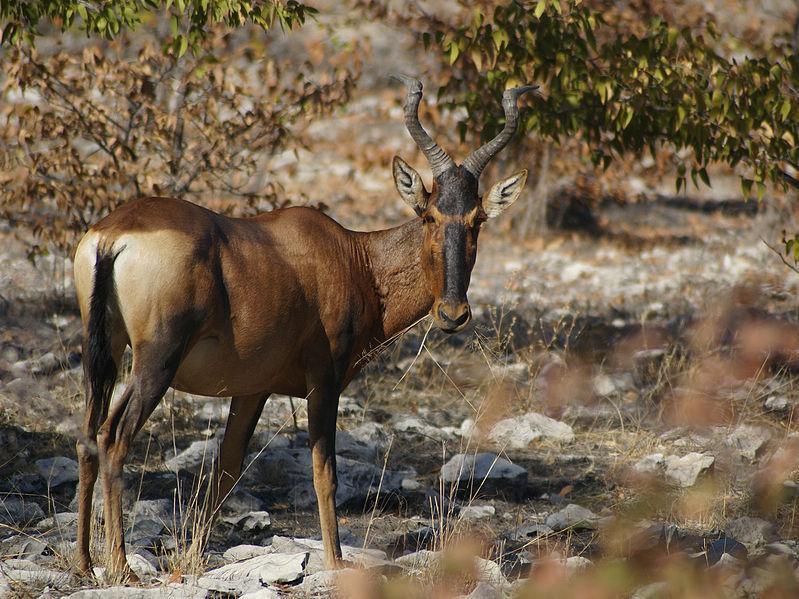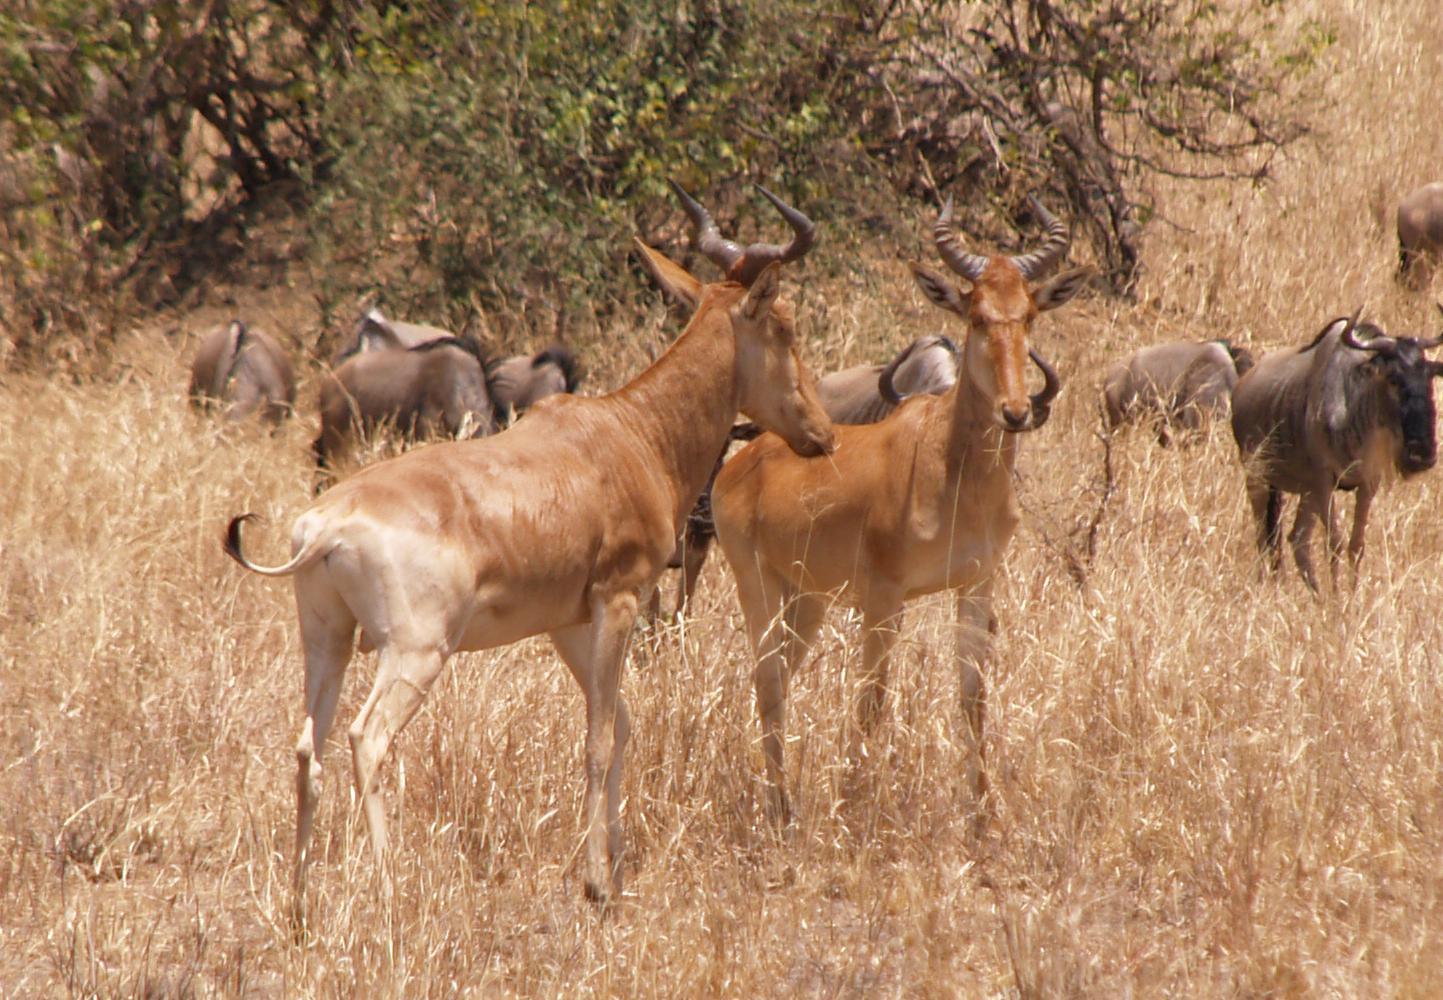The first image is the image on the left, the second image is the image on the right. Assess this claim about the two images: "The left image features more antelopes in the foreground than the right image.". Correct or not? Answer yes or no. No. 